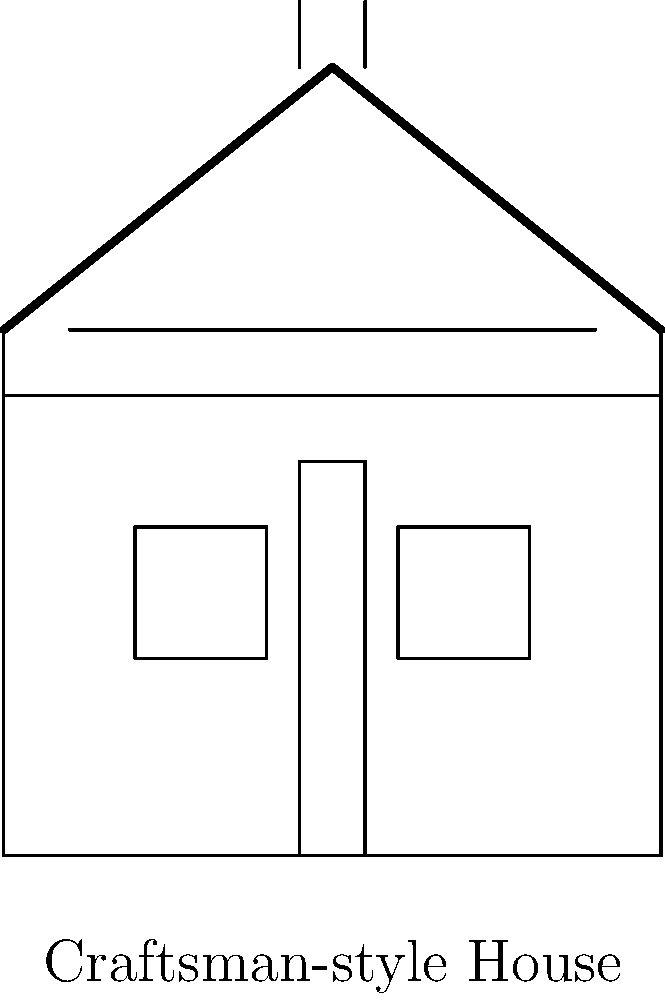Based on the architectural features shown in the image, which prominent style of residential architecture in Pasadena does this facade represent? To identify the architectural style, let's analyze the key features of the building facade:

1. Roof shape: The house has a low-pitched gabled roof, which is a characteristic of Craftsman-style architecture.

2. Exposed rafters: The lines extending beyond the roof edge represent exposed rafters, another hallmark of Craftsman homes.

3. Porch supports: The vertical lines at the edges of the roof suggest thick, square columns supporting the porch roof, typical in Craftsman design.

4. Windows: The facade shows double-hung windows, often found in Craftsman houses.

5. Emphasis on natural materials: While not explicitly shown in the diagram, the overall simplicity of the design suggests an emphasis on natural materials, which is consistent with Craftsman philosophy.

6. Horizontal lines: The strong horizontal lines below the roof emphasize the connection to the earth, a key principle in Craftsman design.

These features collectively point to the Craftsman style, which was popularized in Pasadena in the early 20th century, particularly through the work of Greene and Greene architects. The Craftsman style is closely associated with the Arts and Crafts movement and is a significant part of Pasadena's architectural heritage.
Answer: Craftsman 